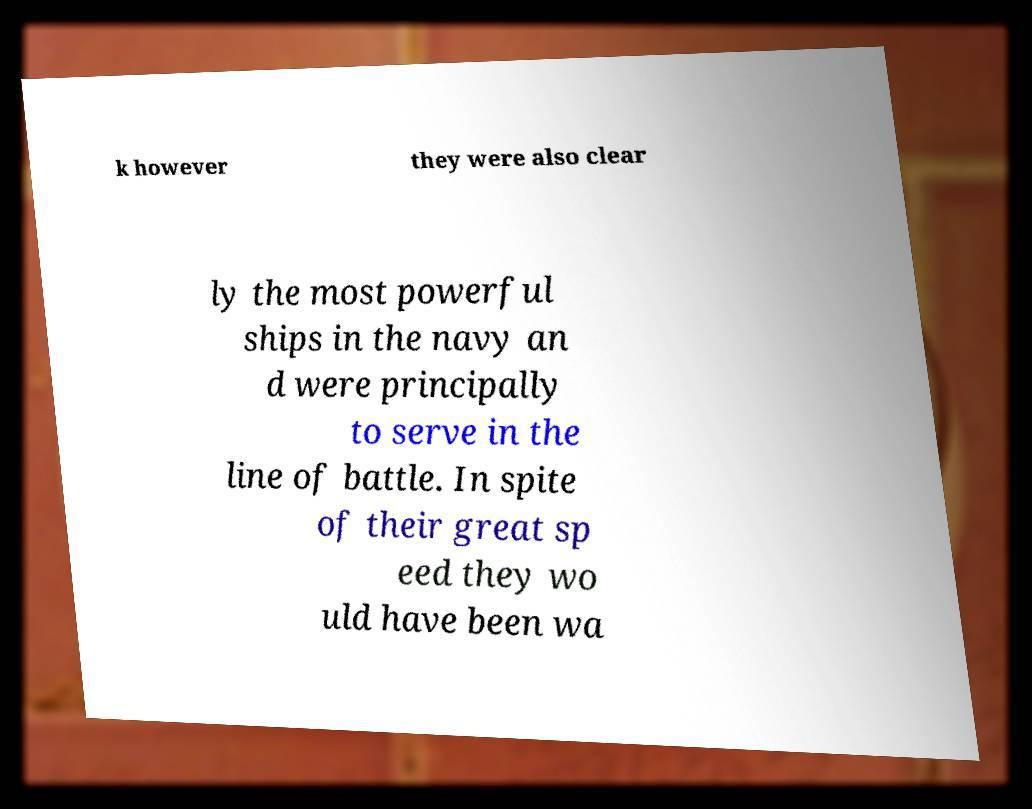Please identify and transcribe the text found in this image. k however they were also clear ly the most powerful ships in the navy an d were principally to serve in the line of battle. In spite of their great sp eed they wo uld have been wa 